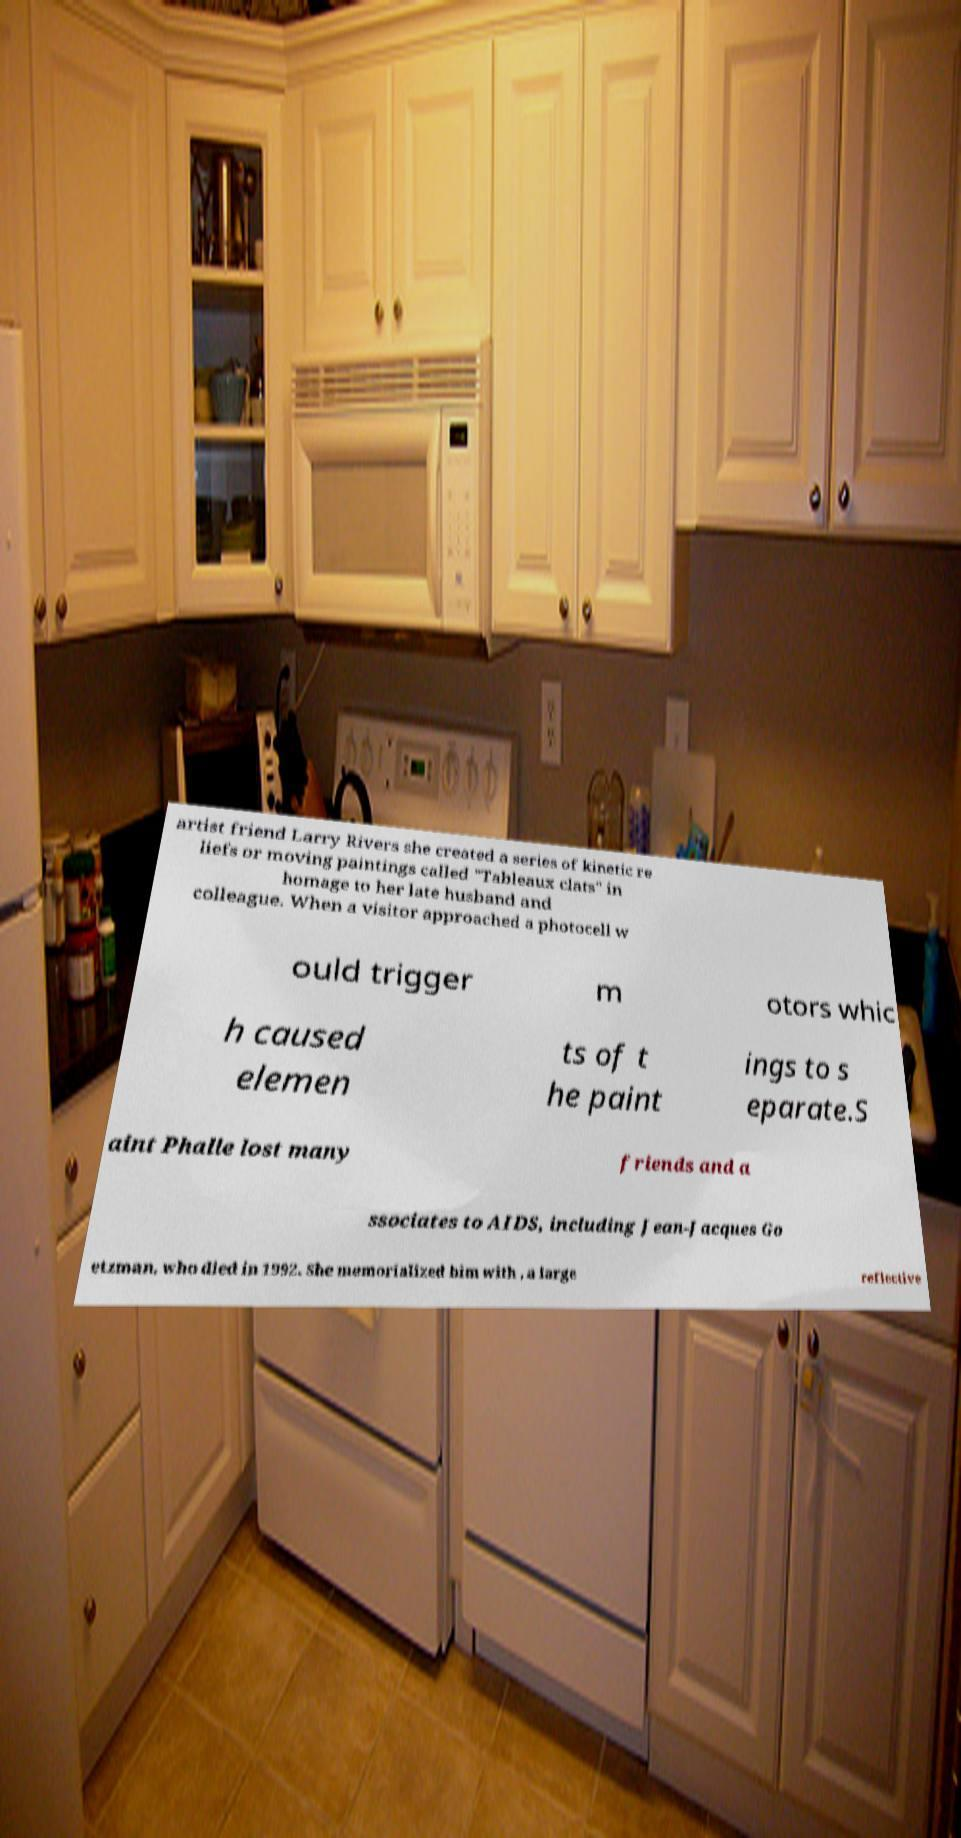Could you extract and type out the text from this image? artist friend Larry Rivers she created a series of kinetic re liefs or moving paintings called "Tableaux clats" in homage to her late husband and colleague. When a visitor approached a photocell w ould trigger m otors whic h caused elemen ts of t he paint ings to s eparate.S aint Phalle lost many friends and a ssociates to AIDS, including Jean-Jacques Go etzman, who died in 1992. She memorialized him with , a large reflective 